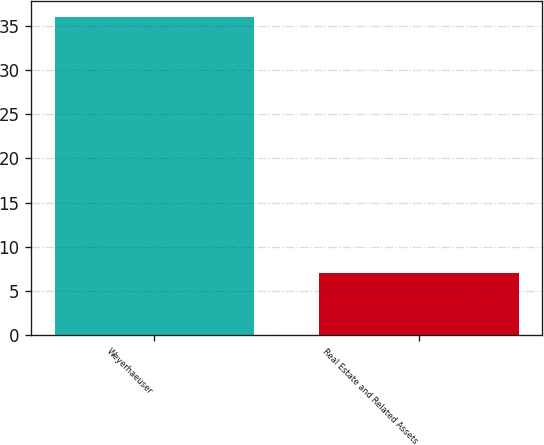Convert chart to OTSL. <chart><loc_0><loc_0><loc_500><loc_500><bar_chart><fcel>Weyerhaeuser<fcel>Real Estate and Related Assets<nl><fcel>36<fcel>7<nl></chart> 